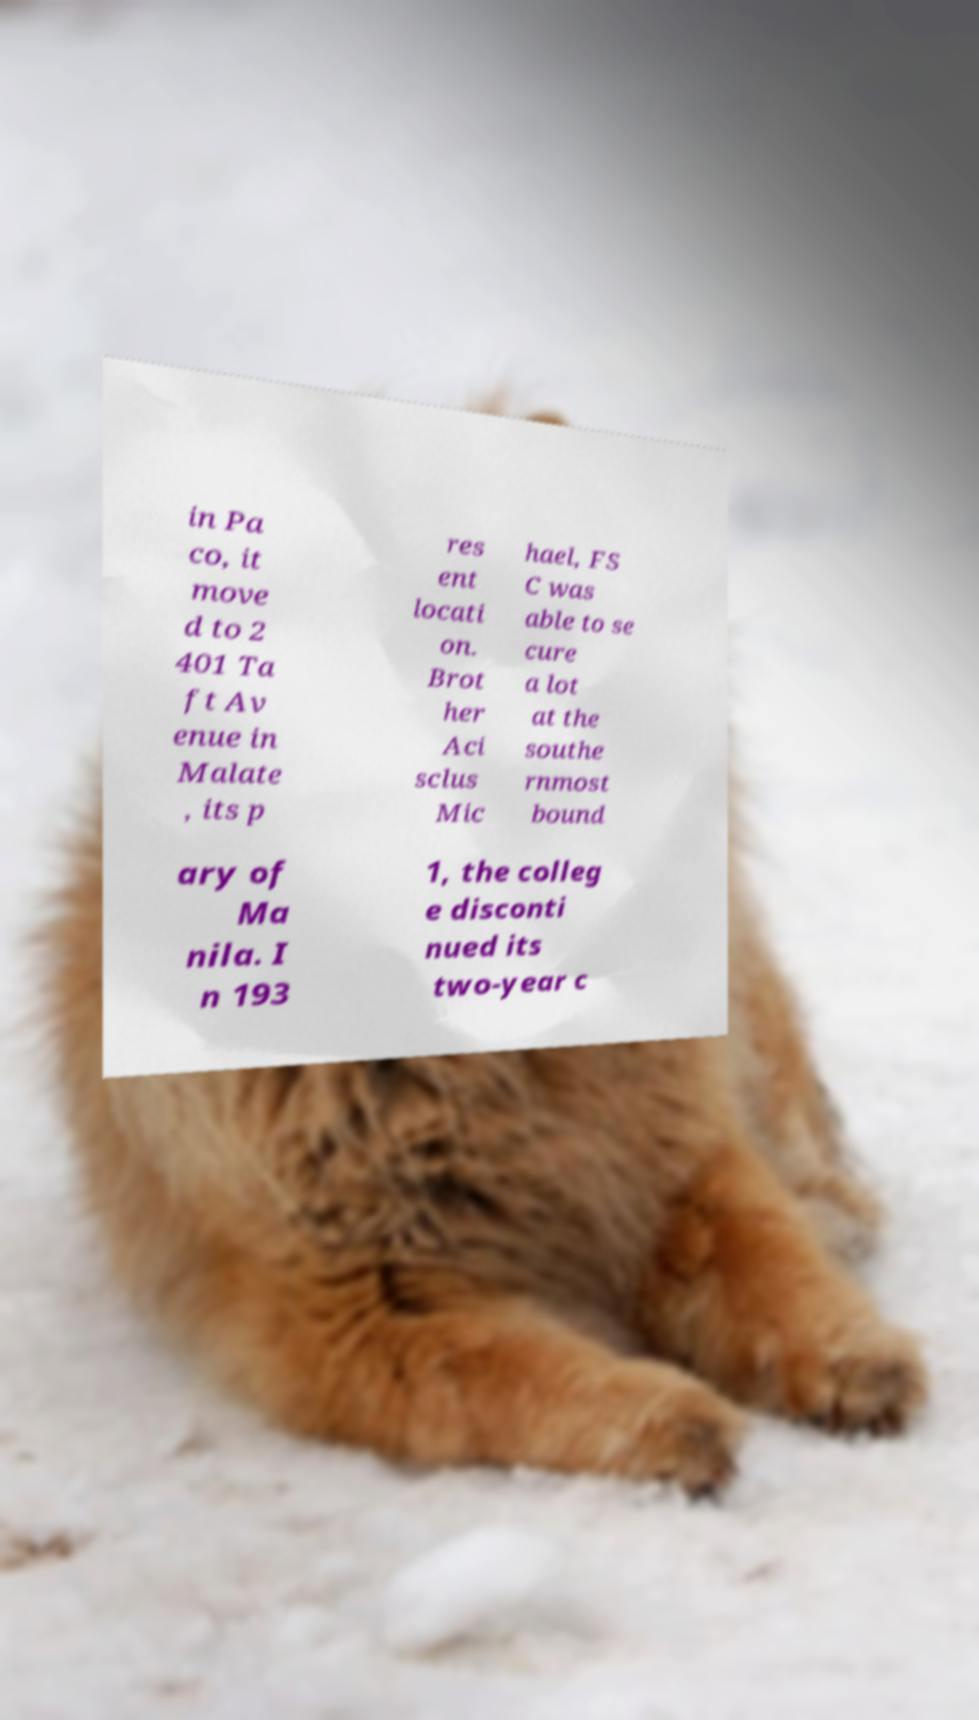Can you accurately transcribe the text from the provided image for me? in Pa co, it move d to 2 401 Ta ft Av enue in Malate , its p res ent locati on. Brot her Aci sclus Mic hael, FS C was able to se cure a lot at the southe rnmost bound ary of Ma nila. I n 193 1, the colleg e disconti nued its two-year c 